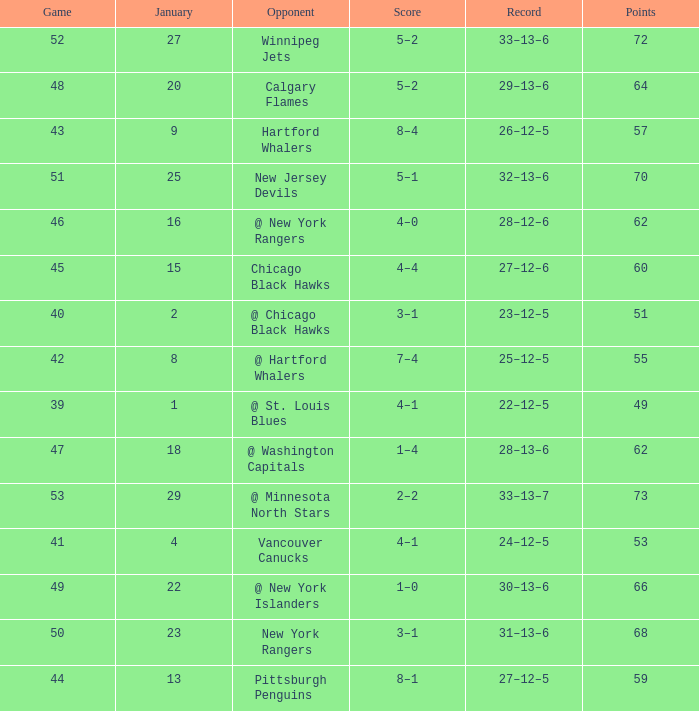Which January has a Score of 7–4, and a Game smaller than 42? None. 